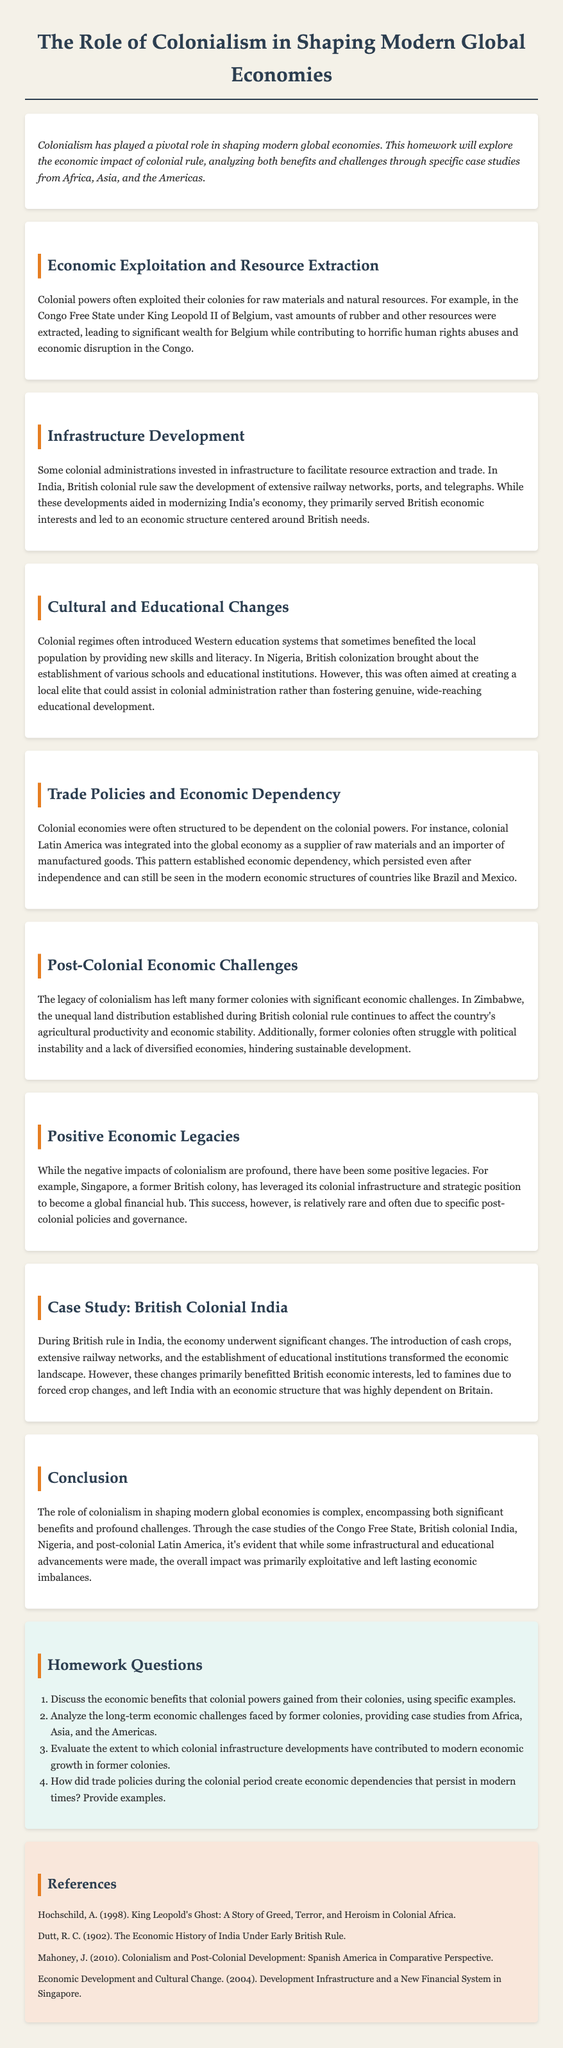What resources were exploited in the Congo Free State? The document states that vast amounts of rubber and other resources were extracted in the Congo Free State under King Leopold II of Belgium.
Answer: rubber What infrastructure did British colonial rule develop in India? The homework mentions the development of extensive railway networks, ports, and telegraphs during British colonial rule in India.
Answer: railway networks Which country is cited as a case study for positive economic legacies of colonialism? The document provides the example of Singapore as a former British colony that leveraged its colonial infrastructure for economic success.
Answer: Singapore What type of education did British colonization bring to Nigeria? The text refers to the establishment of various schools and educational institutions in Nigeria under British colonization.
Answer: schools What historical impact did colonial trade policies have on Latin America? The document explains that colonial economies in Latin America were structured as suppliers of raw materials and importers of manufactured goods, establishing economic dependency.
Answer: economic dependency What is a key challenge mentioned for Zimbabwe post-colonialism? The document indicates that unequal land distribution established during British colonial rule affects Zimbabwe's agricultural productivity.
Answer: land distribution Which colonial power was responsible for the exploitation of resources in the Congo Free State? The text specifies that Belgium, under King Leopold II, was responsible for exploiting resources in the Congo Free State.
Answer: Belgium How did colonialism affect the educational landscape in Nigeria? The document notes that Western education systems were introduced, benefiting a local elite rather than fostering wide-reaching educational development.
Answer: local elite 